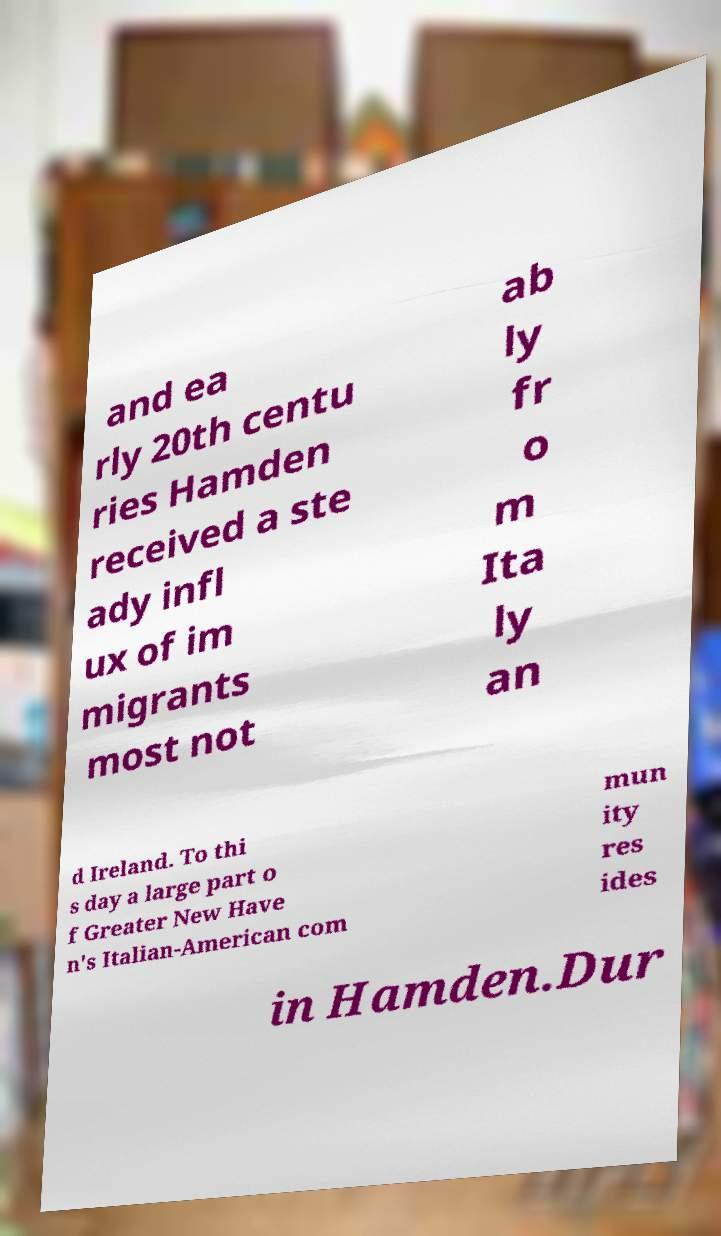I need the written content from this picture converted into text. Can you do that? and ea rly 20th centu ries Hamden received a ste ady infl ux of im migrants most not ab ly fr o m Ita ly an d Ireland. To thi s day a large part o f Greater New Have n's Italian-American com mun ity res ides in Hamden.Dur 